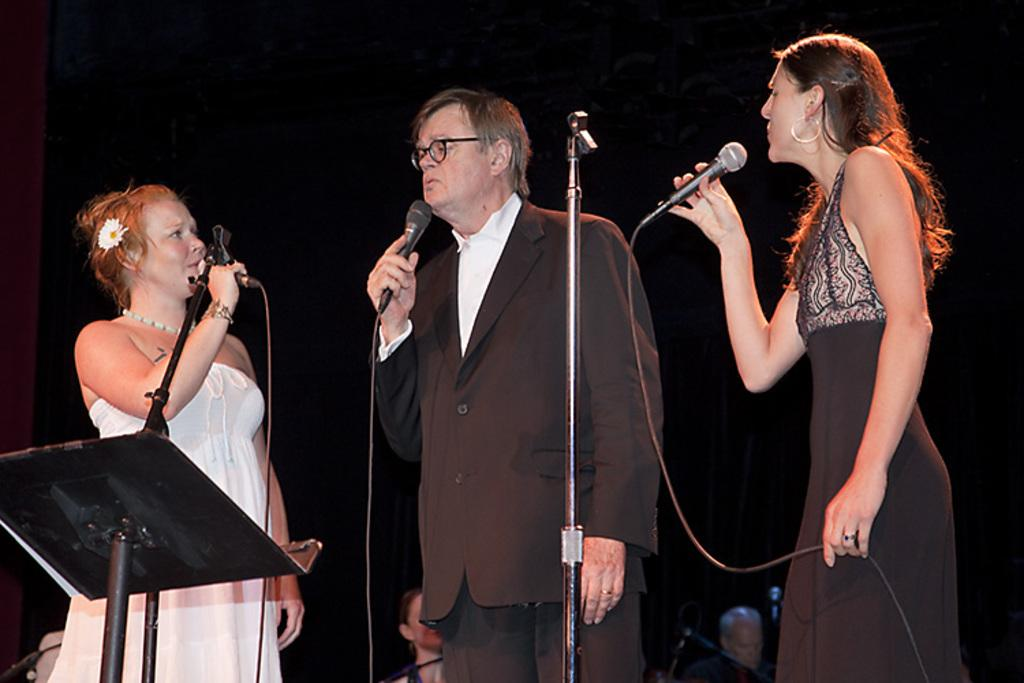How many people are in the image? There are two women and a man in the image, making a total of three people. What are the individuals in the image doing? The individuals are standing and holding microphones, which suggests they might be participating in a performance or presentation. What is in front of the individuals? There is a stand in front of them. Can you describe the background of the image? There are people in the background of the image. How would you describe the lighting in the image? The overall image appears to be dark. What type of car can be seen in the image? There is no car present in the image. What is the plot of the story being told by the individuals in the image? The image does not depict a story or plot; it shows three individuals holding microphones. 